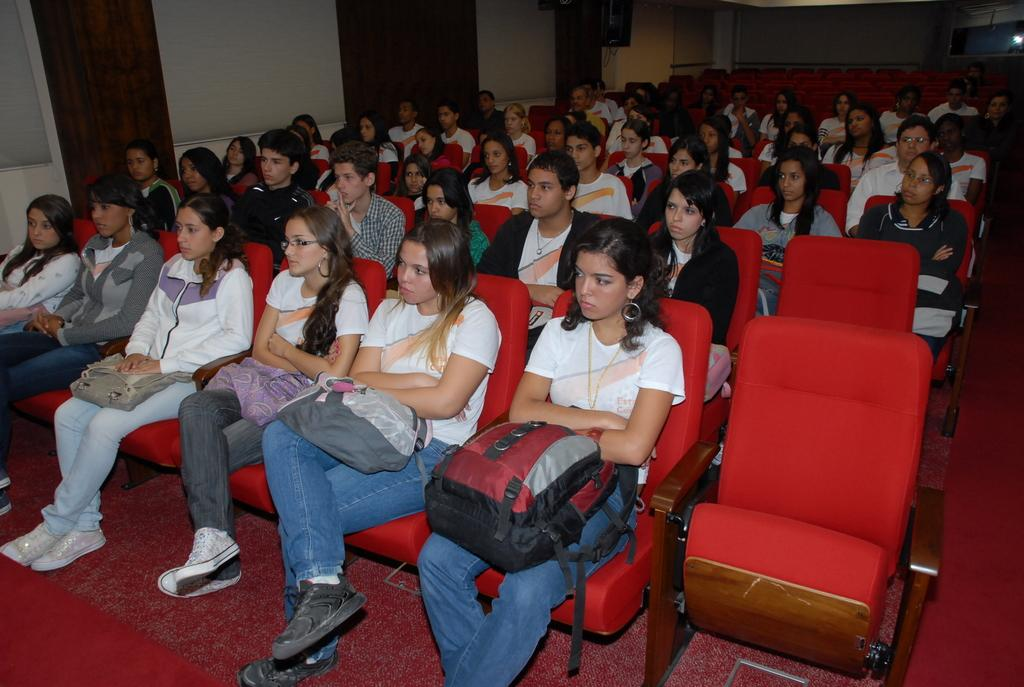Who or what can be seen in the image? There are people in the image. What are the people sitting on? The people are sitting on red chairs. What type of rainstorm is depicted in the image? There is no rainstorm present in the image; it features people sitting on red chairs. What thing is needed to make the chairs more comfortable? The question assumes that the chairs are uncomfortable, which is not mentioned in the provided facts. We cannot determine if anything is needed to make the chairs more comfortable based on the information given. 